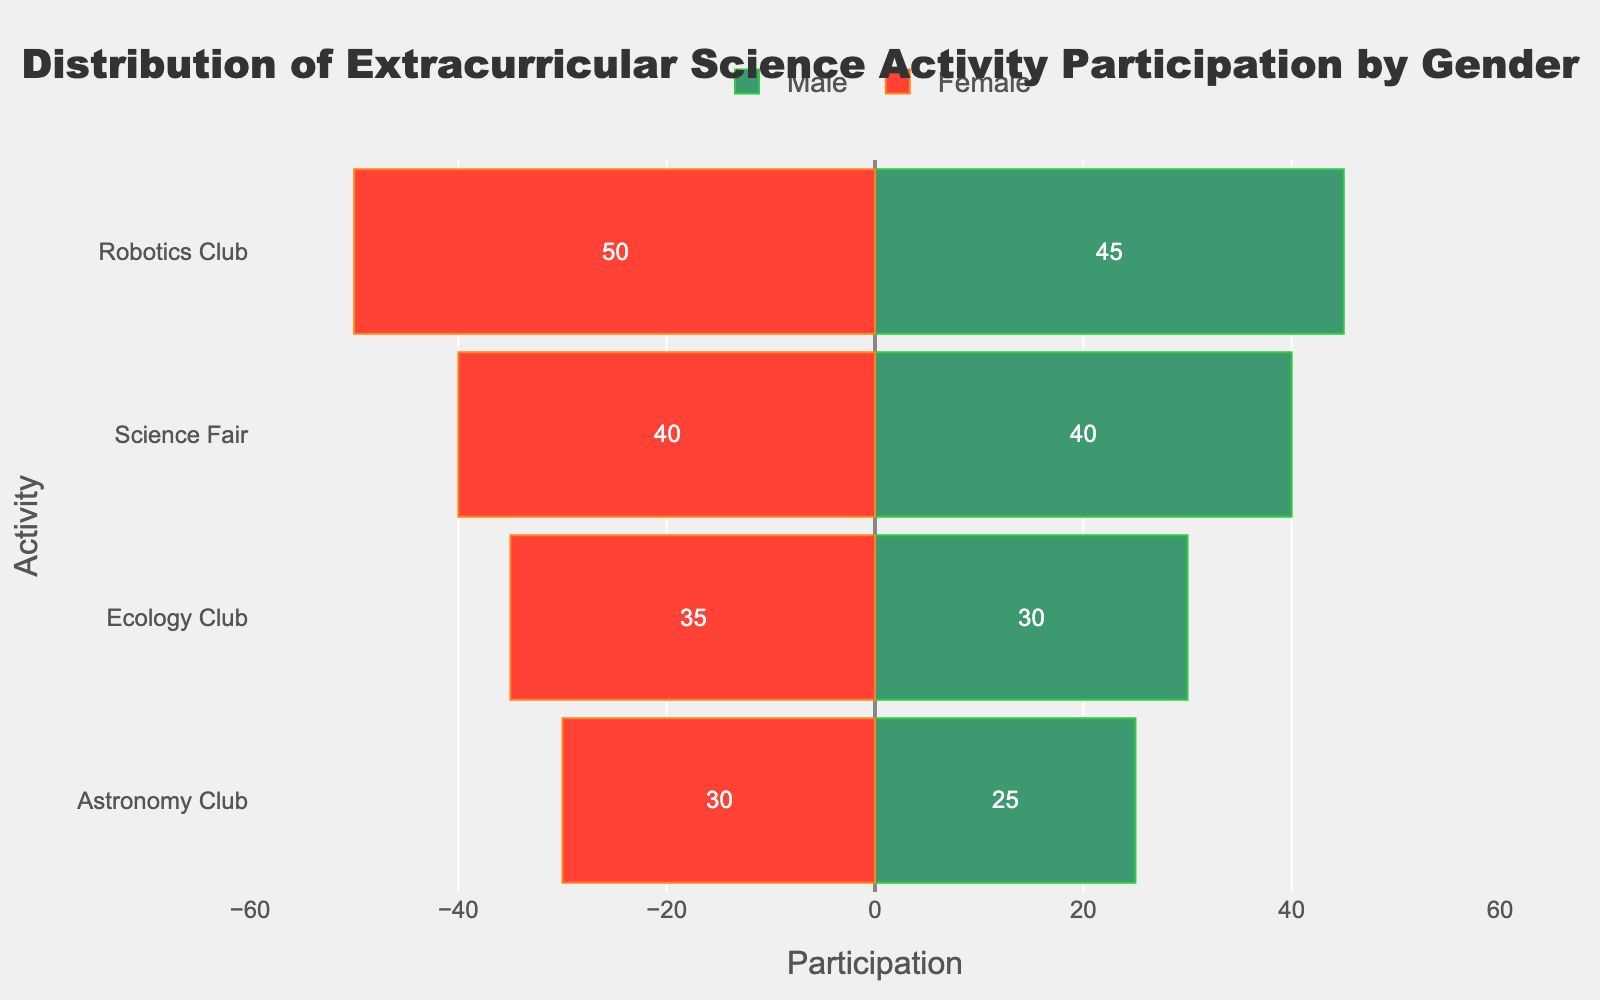What is the total participation for the Robotics Club? The male participation in the Robotics Club is 45, and the female participation is 30. Adding these together: 45 + 30 = 75.
Answer: 75 Which gender has more participants in the Ecology Club? The male participation in the Ecology Club is 30, and the female participation is 35. Comparing these, 35 is greater than 30, so females have more participants.
Answer: Female What is the difference in participation between males and females in the Astronomy Club? The male participation in the Astronomy Club is 25, and the female participation is 40. The difference is: 40 - 25 = 15.
Answer: 15 Which activity has the most female participants? By visually inspecting the length of the red bars, the Science Fair has the highest value at 50 participants.
Answer: Science Fair Is the male participation in any activity higher than the female participation in any activity? The highest male participation is 45 (Robotics Club), whereas the highest female participation is 50 (Science Fair). 45 is less than 50. Therefore, male participation in no activity is higher than the highest female participation.
Answer: No What's the combined participation for the Science Fair activity? The male participation in the Science Fair is 40 and the female participation is 50. Adding these together: 40 + 50 = 90.
Answer: 90 Which activity has the smallest gender gap in participation? The Astronomy Club has 25 male and 40 female participants. The difference is 15. For the Ecology Club, it's 5. The Science Fair has a difference of 10, and the Robotics Club has 15 difference. Thus, the Ecology Club has the smallest gap.
Answer: Ecology Club What percentage of the total Robotics Club participants are male? The total Robotics Club participants are 75. Male participants are 45. The percentage is (45/75) * 100 = 60%.
Answer: 60% Compare male and female participation in the Science Fair. What is the ratio of female to male participants? Male participants in the Science Fair are 40, and female participants are 50. The ratio is 50:40, which simplifies to 5:4.
Answer: 5:4 Which activity has the highest total participation? Summing the male and female participations for each activity:
- Robotics Club: 45 + 30 = 75
- Science Fair: 40 + 50 = 90
- Ecology Club: 30 + 35 = 65
- Astronomy Club: 25 + 40 = 65
The Science Fair has the highest total participation of 90.
Answer: Science Fair 